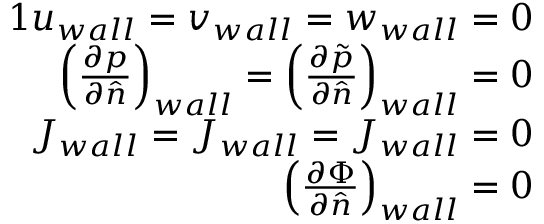<formula> <loc_0><loc_0><loc_500><loc_500>\begin{array} { r } { { 1 } u _ { w a l l } = v _ { w a l l } = w _ { w a l l } = 0 } \\ { \left ( \frac { \partial p } { \partial \hat { n } } \right ) _ { w a l l } = \left ( \frac { \partial \tilde { p } } { \partial \hat { n } } \right ) _ { w a l l } = 0 } \\ { J _ { w a l l } = J _ { w a l l } = J _ { w a l l } = 0 } \\ { \left ( \frac { \partial \Phi } { \partial \hat { n } } \right ) _ { w a l l } = 0 } \end{array}</formula> 